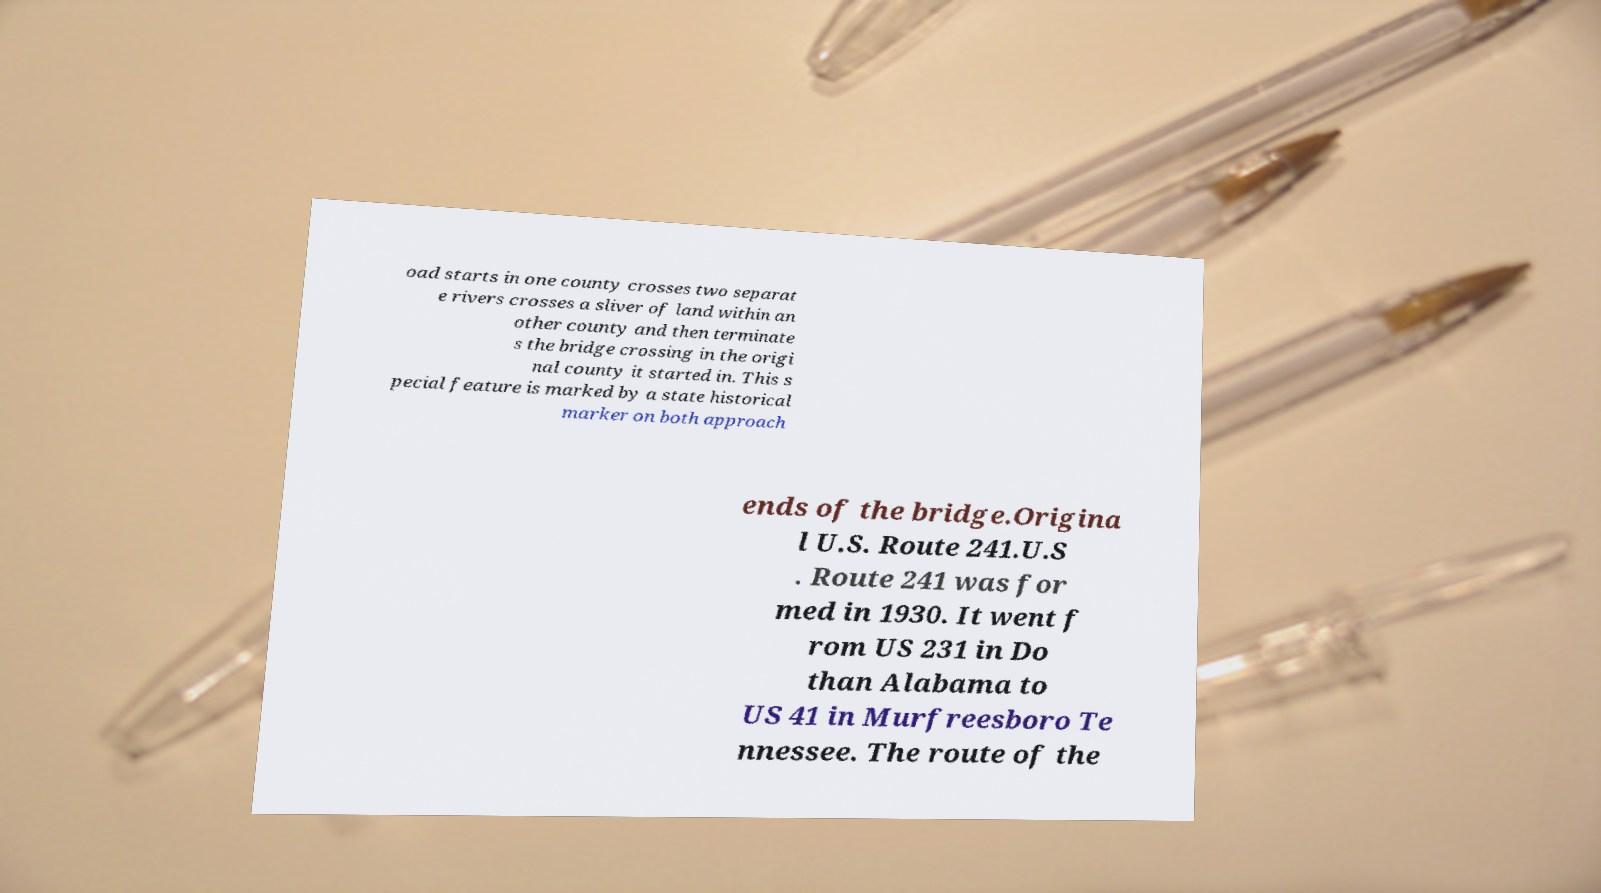Please identify and transcribe the text found in this image. oad starts in one county crosses two separat e rivers crosses a sliver of land within an other county and then terminate s the bridge crossing in the origi nal county it started in. This s pecial feature is marked by a state historical marker on both approach ends of the bridge.Origina l U.S. Route 241.U.S . Route 241 was for med in 1930. It went f rom US 231 in Do than Alabama to US 41 in Murfreesboro Te nnessee. The route of the 